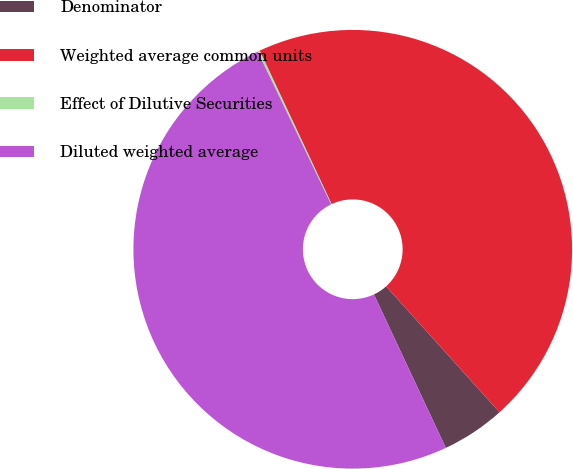Convert chart to OTSL. <chart><loc_0><loc_0><loc_500><loc_500><pie_chart><fcel>Denominator<fcel>Weighted average common units<fcel>Effect of Dilutive Securities<fcel>Diluted weighted average<nl><fcel>4.69%<fcel>45.31%<fcel>0.16%<fcel>49.84%<nl></chart> 